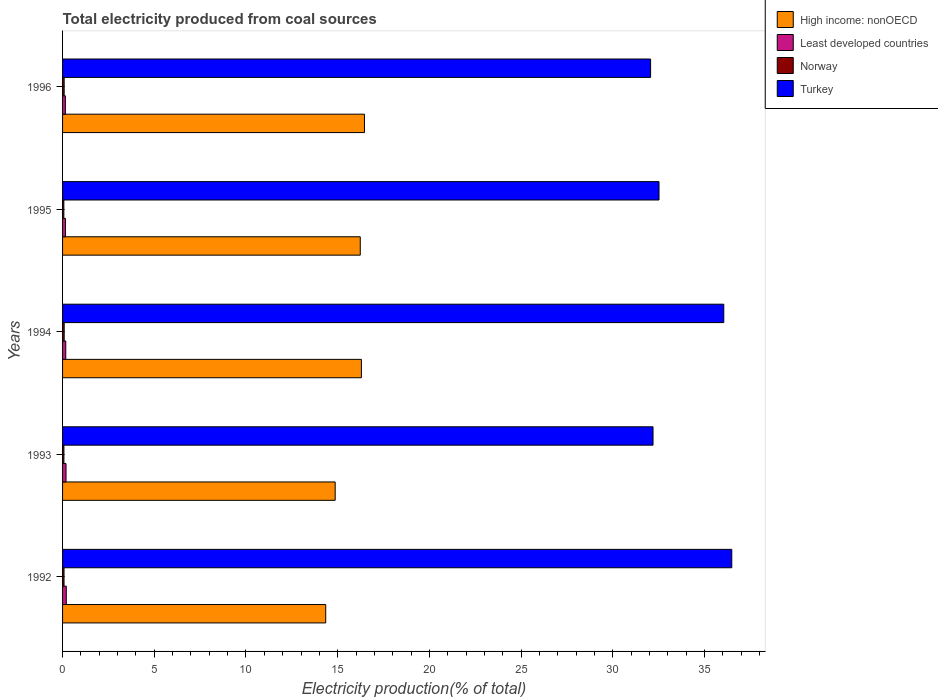How many different coloured bars are there?
Give a very brief answer. 4. Are the number of bars per tick equal to the number of legend labels?
Make the answer very short. Yes. Are the number of bars on each tick of the Y-axis equal?
Ensure brevity in your answer.  Yes. How many bars are there on the 5th tick from the top?
Ensure brevity in your answer.  4. What is the total electricity produced in Turkey in 1995?
Make the answer very short. 32.52. Across all years, what is the maximum total electricity produced in Least developed countries?
Provide a short and direct response. 0.2. Across all years, what is the minimum total electricity produced in Turkey?
Your answer should be very brief. 32.06. In which year was the total electricity produced in High income: nonOECD maximum?
Provide a succinct answer. 1996. What is the total total electricity produced in Turkey in the graph?
Provide a succinct answer. 169.31. What is the difference between the total electricity produced in Least developed countries in 1994 and that in 1995?
Provide a short and direct response. 0.02. What is the difference between the total electricity produced in High income: nonOECD in 1993 and the total electricity produced in Norway in 1992?
Keep it short and to the point. 14.78. What is the average total electricity produced in Least developed countries per year?
Your response must be concise. 0.18. In the year 1992, what is the difference between the total electricity produced in Least developed countries and total electricity produced in Norway?
Your answer should be compact. 0.12. In how many years, is the total electricity produced in Turkey greater than 36 %?
Offer a terse response. 2. What is the ratio of the total electricity produced in Norway in 1994 to that in 1995?
Provide a succinct answer. 1.27. What is the difference between the highest and the second highest total electricity produced in Least developed countries?
Your answer should be compact. 0.01. What is the difference between the highest and the lowest total electricity produced in Least developed countries?
Ensure brevity in your answer.  0.05. Is it the case that in every year, the sum of the total electricity produced in High income: nonOECD and total electricity produced in Least developed countries is greater than the sum of total electricity produced in Turkey and total electricity produced in Norway?
Provide a succinct answer. Yes. What does the 2nd bar from the top in 1996 represents?
Keep it short and to the point. Norway. What does the 2nd bar from the bottom in 1995 represents?
Keep it short and to the point. Least developed countries. Are all the bars in the graph horizontal?
Provide a succinct answer. Yes. How many years are there in the graph?
Keep it short and to the point. 5. What is the difference between two consecutive major ticks on the X-axis?
Ensure brevity in your answer.  5. Are the values on the major ticks of X-axis written in scientific E-notation?
Provide a short and direct response. No. Does the graph contain any zero values?
Your answer should be compact. No. How many legend labels are there?
Ensure brevity in your answer.  4. How are the legend labels stacked?
Ensure brevity in your answer.  Vertical. What is the title of the graph?
Offer a very short reply. Total electricity produced from coal sources. What is the label or title of the X-axis?
Give a very brief answer. Electricity production(% of total). What is the Electricity production(% of total) of High income: nonOECD in 1992?
Your answer should be compact. 14.35. What is the Electricity production(% of total) of Least developed countries in 1992?
Make the answer very short. 0.2. What is the Electricity production(% of total) of Norway in 1992?
Provide a short and direct response. 0.08. What is the Electricity production(% of total) of Turkey in 1992?
Make the answer very short. 36.49. What is the Electricity production(% of total) of High income: nonOECD in 1993?
Your answer should be compact. 14.86. What is the Electricity production(% of total) of Least developed countries in 1993?
Your answer should be compact. 0.19. What is the Electricity production(% of total) of Norway in 1993?
Your answer should be compact. 0.07. What is the Electricity production(% of total) of Turkey in 1993?
Keep it short and to the point. 32.19. What is the Electricity production(% of total) of High income: nonOECD in 1994?
Keep it short and to the point. 16.29. What is the Electricity production(% of total) in Least developed countries in 1994?
Make the answer very short. 0.17. What is the Electricity production(% of total) in Norway in 1994?
Make the answer very short. 0.09. What is the Electricity production(% of total) of Turkey in 1994?
Provide a succinct answer. 36.05. What is the Electricity production(% of total) in High income: nonOECD in 1995?
Keep it short and to the point. 16.23. What is the Electricity production(% of total) in Least developed countries in 1995?
Offer a terse response. 0.16. What is the Electricity production(% of total) in Norway in 1995?
Keep it short and to the point. 0.07. What is the Electricity production(% of total) in Turkey in 1995?
Offer a very short reply. 32.52. What is the Electricity production(% of total) of High income: nonOECD in 1996?
Provide a succinct answer. 16.46. What is the Electricity production(% of total) of Least developed countries in 1996?
Your answer should be compact. 0.15. What is the Electricity production(% of total) in Norway in 1996?
Your answer should be compact. 0.09. What is the Electricity production(% of total) in Turkey in 1996?
Your answer should be very brief. 32.06. Across all years, what is the maximum Electricity production(% of total) in High income: nonOECD?
Offer a terse response. 16.46. Across all years, what is the maximum Electricity production(% of total) of Least developed countries?
Your response must be concise. 0.2. Across all years, what is the maximum Electricity production(% of total) of Norway?
Provide a short and direct response. 0.09. Across all years, what is the maximum Electricity production(% of total) of Turkey?
Offer a terse response. 36.49. Across all years, what is the minimum Electricity production(% of total) in High income: nonOECD?
Your response must be concise. 14.35. Across all years, what is the minimum Electricity production(% of total) of Least developed countries?
Keep it short and to the point. 0.15. Across all years, what is the minimum Electricity production(% of total) in Norway?
Give a very brief answer. 0.07. Across all years, what is the minimum Electricity production(% of total) of Turkey?
Offer a terse response. 32.06. What is the total Electricity production(% of total) of High income: nonOECD in the graph?
Your answer should be compact. 78.19. What is the total Electricity production(% of total) in Least developed countries in the graph?
Your answer should be compact. 0.88. What is the total Electricity production(% of total) of Norway in the graph?
Provide a succinct answer. 0.4. What is the total Electricity production(% of total) in Turkey in the graph?
Ensure brevity in your answer.  169.31. What is the difference between the Electricity production(% of total) in High income: nonOECD in 1992 and that in 1993?
Offer a terse response. -0.52. What is the difference between the Electricity production(% of total) of Least developed countries in 1992 and that in 1993?
Your response must be concise. 0.01. What is the difference between the Electricity production(% of total) of Norway in 1992 and that in 1993?
Keep it short and to the point. 0.01. What is the difference between the Electricity production(% of total) of Turkey in 1992 and that in 1993?
Offer a terse response. 4.29. What is the difference between the Electricity production(% of total) of High income: nonOECD in 1992 and that in 1994?
Offer a very short reply. -1.95. What is the difference between the Electricity production(% of total) of Least developed countries in 1992 and that in 1994?
Provide a succinct answer. 0.03. What is the difference between the Electricity production(% of total) in Norway in 1992 and that in 1994?
Your response must be concise. -0.01. What is the difference between the Electricity production(% of total) in Turkey in 1992 and that in 1994?
Keep it short and to the point. 0.44. What is the difference between the Electricity production(% of total) in High income: nonOECD in 1992 and that in 1995?
Provide a short and direct response. -1.88. What is the difference between the Electricity production(% of total) of Least developed countries in 1992 and that in 1995?
Make the answer very short. 0.04. What is the difference between the Electricity production(% of total) of Norway in 1992 and that in 1995?
Make the answer very short. 0.01. What is the difference between the Electricity production(% of total) in Turkey in 1992 and that in 1995?
Give a very brief answer. 3.97. What is the difference between the Electricity production(% of total) of High income: nonOECD in 1992 and that in 1996?
Ensure brevity in your answer.  -2.11. What is the difference between the Electricity production(% of total) in Least developed countries in 1992 and that in 1996?
Ensure brevity in your answer.  0.05. What is the difference between the Electricity production(% of total) in Norway in 1992 and that in 1996?
Provide a short and direct response. -0.01. What is the difference between the Electricity production(% of total) in Turkey in 1992 and that in 1996?
Provide a short and direct response. 4.43. What is the difference between the Electricity production(% of total) of High income: nonOECD in 1993 and that in 1994?
Keep it short and to the point. -1.43. What is the difference between the Electricity production(% of total) of Least developed countries in 1993 and that in 1994?
Provide a succinct answer. 0.01. What is the difference between the Electricity production(% of total) of Norway in 1993 and that in 1994?
Your response must be concise. -0.01. What is the difference between the Electricity production(% of total) of Turkey in 1993 and that in 1994?
Your answer should be very brief. -3.86. What is the difference between the Electricity production(% of total) in High income: nonOECD in 1993 and that in 1995?
Your response must be concise. -1.37. What is the difference between the Electricity production(% of total) in Least developed countries in 1993 and that in 1995?
Make the answer very short. 0.03. What is the difference between the Electricity production(% of total) in Norway in 1993 and that in 1995?
Offer a terse response. 0. What is the difference between the Electricity production(% of total) in Turkey in 1993 and that in 1995?
Offer a terse response. -0.33. What is the difference between the Electricity production(% of total) of High income: nonOECD in 1993 and that in 1996?
Your response must be concise. -1.6. What is the difference between the Electricity production(% of total) of Least developed countries in 1993 and that in 1996?
Give a very brief answer. 0.04. What is the difference between the Electricity production(% of total) of Norway in 1993 and that in 1996?
Offer a very short reply. -0.01. What is the difference between the Electricity production(% of total) in Turkey in 1993 and that in 1996?
Keep it short and to the point. 0.13. What is the difference between the Electricity production(% of total) of High income: nonOECD in 1994 and that in 1995?
Keep it short and to the point. 0.06. What is the difference between the Electricity production(% of total) in Least developed countries in 1994 and that in 1995?
Make the answer very short. 0.02. What is the difference between the Electricity production(% of total) in Norway in 1994 and that in 1995?
Your answer should be very brief. 0.02. What is the difference between the Electricity production(% of total) of Turkey in 1994 and that in 1995?
Your answer should be very brief. 3.53. What is the difference between the Electricity production(% of total) in High income: nonOECD in 1994 and that in 1996?
Your answer should be very brief. -0.17. What is the difference between the Electricity production(% of total) of Least developed countries in 1994 and that in 1996?
Provide a succinct answer. 0.02. What is the difference between the Electricity production(% of total) of Norway in 1994 and that in 1996?
Offer a terse response. 0. What is the difference between the Electricity production(% of total) of Turkey in 1994 and that in 1996?
Your answer should be compact. 3.99. What is the difference between the Electricity production(% of total) of High income: nonOECD in 1995 and that in 1996?
Offer a terse response. -0.23. What is the difference between the Electricity production(% of total) in Least developed countries in 1995 and that in 1996?
Ensure brevity in your answer.  0.01. What is the difference between the Electricity production(% of total) of Norway in 1995 and that in 1996?
Make the answer very short. -0.02. What is the difference between the Electricity production(% of total) of Turkey in 1995 and that in 1996?
Your answer should be very brief. 0.46. What is the difference between the Electricity production(% of total) in High income: nonOECD in 1992 and the Electricity production(% of total) in Least developed countries in 1993?
Your response must be concise. 14.16. What is the difference between the Electricity production(% of total) in High income: nonOECD in 1992 and the Electricity production(% of total) in Norway in 1993?
Offer a very short reply. 14.27. What is the difference between the Electricity production(% of total) of High income: nonOECD in 1992 and the Electricity production(% of total) of Turkey in 1993?
Your answer should be compact. -17.85. What is the difference between the Electricity production(% of total) in Least developed countries in 1992 and the Electricity production(% of total) in Norway in 1993?
Keep it short and to the point. 0.13. What is the difference between the Electricity production(% of total) in Least developed countries in 1992 and the Electricity production(% of total) in Turkey in 1993?
Offer a very short reply. -31.99. What is the difference between the Electricity production(% of total) in Norway in 1992 and the Electricity production(% of total) in Turkey in 1993?
Ensure brevity in your answer.  -32.11. What is the difference between the Electricity production(% of total) of High income: nonOECD in 1992 and the Electricity production(% of total) of Least developed countries in 1994?
Your answer should be very brief. 14.17. What is the difference between the Electricity production(% of total) in High income: nonOECD in 1992 and the Electricity production(% of total) in Norway in 1994?
Your answer should be compact. 14.26. What is the difference between the Electricity production(% of total) of High income: nonOECD in 1992 and the Electricity production(% of total) of Turkey in 1994?
Offer a very short reply. -21.7. What is the difference between the Electricity production(% of total) in Least developed countries in 1992 and the Electricity production(% of total) in Norway in 1994?
Make the answer very short. 0.11. What is the difference between the Electricity production(% of total) of Least developed countries in 1992 and the Electricity production(% of total) of Turkey in 1994?
Make the answer very short. -35.85. What is the difference between the Electricity production(% of total) of Norway in 1992 and the Electricity production(% of total) of Turkey in 1994?
Make the answer very short. -35.97. What is the difference between the Electricity production(% of total) of High income: nonOECD in 1992 and the Electricity production(% of total) of Least developed countries in 1995?
Keep it short and to the point. 14.19. What is the difference between the Electricity production(% of total) in High income: nonOECD in 1992 and the Electricity production(% of total) in Norway in 1995?
Your answer should be compact. 14.28. What is the difference between the Electricity production(% of total) of High income: nonOECD in 1992 and the Electricity production(% of total) of Turkey in 1995?
Ensure brevity in your answer.  -18.17. What is the difference between the Electricity production(% of total) of Least developed countries in 1992 and the Electricity production(% of total) of Norway in 1995?
Provide a succinct answer. 0.13. What is the difference between the Electricity production(% of total) in Least developed countries in 1992 and the Electricity production(% of total) in Turkey in 1995?
Your response must be concise. -32.32. What is the difference between the Electricity production(% of total) of Norway in 1992 and the Electricity production(% of total) of Turkey in 1995?
Offer a terse response. -32.44. What is the difference between the Electricity production(% of total) of High income: nonOECD in 1992 and the Electricity production(% of total) of Least developed countries in 1996?
Ensure brevity in your answer.  14.2. What is the difference between the Electricity production(% of total) of High income: nonOECD in 1992 and the Electricity production(% of total) of Norway in 1996?
Provide a short and direct response. 14.26. What is the difference between the Electricity production(% of total) of High income: nonOECD in 1992 and the Electricity production(% of total) of Turkey in 1996?
Make the answer very short. -17.71. What is the difference between the Electricity production(% of total) of Least developed countries in 1992 and the Electricity production(% of total) of Norway in 1996?
Make the answer very short. 0.12. What is the difference between the Electricity production(% of total) of Least developed countries in 1992 and the Electricity production(% of total) of Turkey in 1996?
Make the answer very short. -31.86. What is the difference between the Electricity production(% of total) in Norway in 1992 and the Electricity production(% of total) in Turkey in 1996?
Give a very brief answer. -31.98. What is the difference between the Electricity production(% of total) of High income: nonOECD in 1993 and the Electricity production(% of total) of Least developed countries in 1994?
Provide a succinct answer. 14.69. What is the difference between the Electricity production(% of total) in High income: nonOECD in 1993 and the Electricity production(% of total) in Norway in 1994?
Your answer should be very brief. 14.77. What is the difference between the Electricity production(% of total) of High income: nonOECD in 1993 and the Electricity production(% of total) of Turkey in 1994?
Your response must be concise. -21.19. What is the difference between the Electricity production(% of total) of Least developed countries in 1993 and the Electricity production(% of total) of Norway in 1994?
Your answer should be very brief. 0.1. What is the difference between the Electricity production(% of total) in Least developed countries in 1993 and the Electricity production(% of total) in Turkey in 1994?
Ensure brevity in your answer.  -35.86. What is the difference between the Electricity production(% of total) in Norway in 1993 and the Electricity production(% of total) in Turkey in 1994?
Keep it short and to the point. -35.98. What is the difference between the Electricity production(% of total) of High income: nonOECD in 1993 and the Electricity production(% of total) of Least developed countries in 1995?
Keep it short and to the point. 14.7. What is the difference between the Electricity production(% of total) of High income: nonOECD in 1993 and the Electricity production(% of total) of Norway in 1995?
Your answer should be compact. 14.79. What is the difference between the Electricity production(% of total) in High income: nonOECD in 1993 and the Electricity production(% of total) in Turkey in 1995?
Keep it short and to the point. -17.66. What is the difference between the Electricity production(% of total) of Least developed countries in 1993 and the Electricity production(% of total) of Norway in 1995?
Provide a succinct answer. 0.12. What is the difference between the Electricity production(% of total) in Least developed countries in 1993 and the Electricity production(% of total) in Turkey in 1995?
Offer a very short reply. -32.33. What is the difference between the Electricity production(% of total) in Norway in 1993 and the Electricity production(% of total) in Turkey in 1995?
Offer a very short reply. -32.45. What is the difference between the Electricity production(% of total) of High income: nonOECD in 1993 and the Electricity production(% of total) of Least developed countries in 1996?
Your response must be concise. 14.71. What is the difference between the Electricity production(% of total) of High income: nonOECD in 1993 and the Electricity production(% of total) of Norway in 1996?
Give a very brief answer. 14.78. What is the difference between the Electricity production(% of total) in High income: nonOECD in 1993 and the Electricity production(% of total) in Turkey in 1996?
Offer a very short reply. -17.2. What is the difference between the Electricity production(% of total) of Least developed countries in 1993 and the Electricity production(% of total) of Norway in 1996?
Your response must be concise. 0.1. What is the difference between the Electricity production(% of total) of Least developed countries in 1993 and the Electricity production(% of total) of Turkey in 1996?
Keep it short and to the point. -31.87. What is the difference between the Electricity production(% of total) in Norway in 1993 and the Electricity production(% of total) in Turkey in 1996?
Offer a terse response. -31.99. What is the difference between the Electricity production(% of total) of High income: nonOECD in 1994 and the Electricity production(% of total) of Least developed countries in 1995?
Provide a short and direct response. 16.13. What is the difference between the Electricity production(% of total) in High income: nonOECD in 1994 and the Electricity production(% of total) in Norway in 1995?
Make the answer very short. 16.22. What is the difference between the Electricity production(% of total) of High income: nonOECD in 1994 and the Electricity production(% of total) of Turkey in 1995?
Provide a short and direct response. -16.23. What is the difference between the Electricity production(% of total) of Least developed countries in 1994 and the Electricity production(% of total) of Norway in 1995?
Offer a terse response. 0.1. What is the difference between the Electricity production(% of total) of Least developed countries in 1994 and the Electricity production(% of total) of Turkey in 1995?
Your answer should be compact. -32.35. What is the difference between the Electricity production(% of total) of Norway in 1994 and the Electricity production(% of total) of Turkey in 1995?
Give a very brief answer. -32.43. What is the difference between the Electricity production(% of total) in High income: nonOECD in 1994 and the Electricity production(% of total) in Least developed countries in 1996?
Your answer should be very brief. 16.14. What is the difference between the Electricity production(% of total) in High income: nonOECD in 1994 and the Electricity production(% of total) in Norway in 1996?
Give a very brief answer. 16.21. What is the difference between the Electricity production(% of total) of High income: nonOECD in 1994 and the Electricity production(% of total) of Turkey in 1996?
Keep it short and to the point. -15.77. What is the difference between the Electricity production(% of total) in Least developed countries in 1994 and the Electricity production(% of total) in Norway in 1996?
Provide a succinct answer. 0.09. What is the difference between the Electricity production(% of total) in Least developed countries in 1994 and the Electricity production(% of total) in Turkey in 1996?
Make the answer very short. -31.89. What is the difference between the Electricity production(% of total) in Norway in 1994 and the Electricity production(% of total) in Turkey in 1996?
Provide a short and direct response. -31.97. What is the difference between the Electricity production(% of total) of High income: nonOECD in 1995 and the Electricity production(% of total) of Least developed countries in 1996?
Keep it short and to the point. 16.08. What is the difference between the Electricity production(% of total) in High income: nonOECD in 1995 and the Electricity production(% of total) in Norway in 1996?
Offer a very short reply. 16.14. What is the difference between the Electricity production(% of total) of High income: nonOECD in 1995 and the Electricity production(% of total) of Turkey in 1996?
Keep it short and to the point. -15.83. What is the difference between the Electricity production(% of total) in Least developed countries in 1995 and the Electricity production(% of total) in Norway in 1996?
Provide a short and direct response. 0.07. What is the difference between the Electricity production(% of total) in Least developed countries in 1995 and the Electricity production(% of total) in Turkey in 1996?
Provide a short and direct response. -31.9. What is the difference between the Electricity production(% of total) of Norway in 1995 and the Electricity production(% of total) of Turkey in 1996?
Offer a terse response. -31.99. What is the average Electricity production(% of total) in High income: nonOECD per year?
Offer a very short reply. 15.64. What is the average Electricity production(% of total) in Least developed countries per year?
Provide a short and direct response. 0.18. What is the average Electricity production(% of total) of Norway per year?
Make the answer very short. 0.08. What is the average Electricity production(% of total) in Turkey per year?
Provide a succinct answer. 33.86. In the year 1992, what is the difference between the Electricity production(% of total) of High income: nonOECD and Electricity production(% of total) of Least developed countries?
Keep it short and to the point. 14.14. In the year 1992, what is the difference between the Electricity production(% of total) of High income: nonOECD and Electricity production(% of total) of Norway?
Provide a succinct answer. 14.27. In the year 1992, what is the difference between the Electricity production(% of total) in High income: nonOECD and Electricity production(% of total) in Turkey?
Offer a terse response. -22.14. In the year 1992, what is the difference between the Electricity production(% of total) in Least developed countries and Electricity production(% of total) in Norway?
Offer a very short reply. 0.12. In the year 1992, what is the difference between the Electricity production(% of total) of Least developed countries and Electricity production(% of total) of Turkey?
Ensure brevity in your answer.  -36.28. In the year 1992, what is the difference between the Electricity production(% of total) of Norway and Electricity production(% of total) of Turkey?
Keep it short and to the point. -36.41. In the year 1993, what is the difference between the Electricity production(% of total) in High income: nonOECD and Electricity production(% of total) in Least developed countries?
Your answer should be very brief. 14.67. In the year 1993, what is the difference between the Electricity production(% of total) of High income: nonOECD and Electricity production(% of total) of Norway?
Provide a succinct answer. 14.79. In the year 1993, what is the difference between the Electricity production(% of total) in High income: nonOECD and Electricity production(% of total) in Turkey?
Ensure brevity in your answer.  -17.33. In the year 1993, what is the difference between the Electricity production(% of total) in Least developed countries and Electricity production(% of total) in Norway?
Offer a terse response. 0.11. In the year 1993, what is the difference between the Electricity production(% of total) in Least developed countries and Electricity production(% of total) in Turkey?
Your response must be concise. -32. In the year 1993, what is the difference between the Electricity production(% of total) of Norway and Electricity production(% of total) of Turkey?
Keep it short and to the point. -32.12. In the year 1994, what is the difference between the Electricity production(% of total) of High income: nonOECD and Electricity production(% of total) of Least developed countries?
Provide a succinct answer. 16.12. In the year 1994, what is the difference between the Electricity production(% of total) of High income: nonOECD and Electricity production(% of total) of Norway?
Offer a very short reply. 16.2. In the year 1994, what is the difference between the Electricity production(% of total) in High income: nonOECD and Electricity production(% of total) in Turkey?
Provide a short and direct response. -19.76. In the year 1994, what is the difference between the Electricity production(% of total) of Least developed countries and Electricity production(% of total) of Norway?
Provide a short and direct response. 0.09. In the year 1994, what is the difference between the Electricity production(% of total) in Least developed countries and Electricity production(% of total) in Turkey?
Make the answer very short. -35.88. In the year 1994, what is the difference between the Electricity production(% of total) of Norway and Electricity production(% of total) of Turkey?
Keep it short and to the point. -35.96. In the year 1995, what is the difference between the Electricity production(% of total) in High income: nonOECD and Electricity production(% of total) in Least developed countries?
Keep it short and to the point. 16.07. In the year 1995, what is the difference between the Electricity production(% of total) of High income: nonOECD and Electricity production(% of total) of Norway?
Offer a terse response. 16.16. In the year 1995, what is the difference between the Electricity production(% of total) in High income: nonOECD and Electricity production(% of total) in Turkey?
Give a very brief answer. -16.29. In the year 1995, what is the difference between the Electricity production(% of total) in Least developed countries and Electricity production(% of total) in Norway?
Your response must be concise. 0.09. In the year 1995, what is the difference between the Electricity production(% of total) of Least developed countries and Electricity production(% of total) of Turkey?
Your answer should be compact. -32.36. In the year 1995, what is the difference between the Electricity production(% of total) in Norway and Electricity production(% of total) in Turkey?
Ensure brevity in your answer.  -32.45. In the year 1996, what is the difference between the Electricity production(% of total) of High income: nonOECD and Electricity production(% of total) of Least developed countries?
Offer a very short reply. 16.31. In the year 1996, what is the difference between the Electricity production(% of total) in High income: nonOECD and Electricity production(% of total) in Norway?
Your response must be concise. 16.37. In the year 1996, what is the difference between the Electricity production(% of total) of High income: nonOECD and Electricity production(% of total) of Turkey?
Keep it short and to the point. -15.6. In the year 1996, what is the difference between the Electricity production(% of total) in Least developed countries and Electricity production(% of total) in Norway?
Offer a terse response. 0.07. In the year 1996, what is the difference between the Electricity production(% of total) of Least developed countries and Electricity production(% of total) of Turkey?
Make the answer very short. -31.91. In the year 1996, what is the difference between the Electricity production(% of total) in Norway and Electricity production(% of total) in Turkey?
Offer a terse response. -31.97. What is the ratio of the Electricity production(% of total) in High income: nonOECD in 1992 to that in 1993?
Your answer should be very brief. 0.97. What is the ratio of the Electricity production(% of total) of Least developed countries in 1992 to that in 1993?
Offer a terse response. 1.08. What is the ratio of the Electricity production(% of total) of Norway in 1992 to that in 1993?
Ensure brevity in your answer.  1.08. What is the ratio of the Electricity production(% of total) of Turkey in 1992 to that in 1993?
Your response must be concise. 1.13. What is the ratio of the Electricity production(% of total) in High income: nonOECD in 1992 to that in 1994?
Make the answer very short. 0.88. What is the ratio of the Electricity production(% of total) in Least developed countries in 1992 to that in 1994?
Make the answer very short. 1.16. What is the ratio of the Electricity production(% of total) in Norway in 1992 to that in 1994?
Offer a very short reply. 0.91. What is the ratio of the Electricity production(% of total) in Turkey in 1992 to that in 1994?
Give a very brief answer. 1.01. What is the ratio of the Electricity production(% of total) of High income: nonOECD in 1992 to that in 1995?
Ensure brevity in your answer.  0.88. What is the ratio of the Electricity production(% of total) in Least developed countries in 1992 to that in 1995?
Provide a succinct answer. 1.28. What is the ratio of the Electricity production(% of total) of Norway in 1992 to that in 1995?
Give a very brief answer. 1.15. What is the ratio of the Electricity production(% of total) in Turkey in 1992 to that in 1995?
Your response must be concise. 1.12. What is the ratio of the Electricity production(% of total) of High income: nonOECD in 1992 to that in 1996?
Offer a terse response. 0.87. What is the ratio of the Electricity production(% of total) of Least developed countries in 1992 to that in 1996?
Provide a succinct answer. 1.34. What is the ratio of the Electricity production(% of total) in Norway in 1992 to that in 1996?
Your answer should be very brief. 0.92. What is the ratio of the Electricity production(% of total) in Turkey in 1992 to that in 1996?
Offer a very short reply. 1.14. What is the ratio of the Electricity production(% of total) in High income: nonOECD in 1993 to that in 1994?
Your answer should be compact. 0.91. What is the ratio of the Electricity production(% of total) in Least developed countries in 1993 to that in 1994?
Offer a very short reply. 1.08. What is the ratio of the Electricity production(% of total) in Norway in 1993 to that in 1994?
Ensure brevity in your answer.  0.84. What is the ratio of the Electricity production(% of total) in Turkey in 1993 to that in 1994?
Your response must be concise. 0.89. What is the ratio of the Electricity production(% of total) of High income: nonOECD in 1993 to that in 1995?
Your answer should be compact. 0.92. What is the ratio of the Electricity production(% of total) of Least developed countries in 1993 to that in 1995?
Offer a very short reply. 1.18. What is the ratio of the Electricity production(% of total) in Norway in 1993 to that in 1995?
Provide a short and direct response. 1.07. What is the ratio of the Electricity production(% of total) of High income: nonOECD in 1993 to that in 1996?
Keep it short and to the point. 0.9. What is the ratio of the Electricity production(% of total) of Least developed countries in 1993 to that in 1996?
Ensure brevity in your answer.  1.24. What is the ratio of the Electricity production(% of total) in Norway in 1993 to that in 1996?
Give a very brief answer. 0.86. What is the ratio of the Electricity production(% of total) in Turkey in 1993 to that in 1996?
Offer a terse response. 1. What is the ratio of the Electricity production(% of total) in High income: nonOECD in 1994 to that in 1995?
Offer a terse response. 1. What is the ratio of the Electricity production(% of total) of Least developed countries in 1994 to that in 1995?
Offer a terse response. 1.09. What is the ratio of the Electricity production(% of total) of Norway in 1994 to that in 1995?
Ensure brevity in your answer.  1.27. What is the ratio of the Electricity production(% of total) in Turkey in 1994 to that in 1995?
Provide a succinct answer. 1.11. What is the ratio of the Electricity production(% of total) of Least developed countries in 1994 to that in 1996?
Your response must be concise. 1.15. What is the ratio of the Electricity production(% of total) of Norway in 1994 to that in 1996?
Your response must be concise. 1.01. What is the ratio of the Electricity production(% of total) of Turkey in 1994 to that in 1996?
Your answer should be very brief. 1.12. What is the ratio of the Electricity production(% of total) of High income: nonOECD in 1995 to that in 1996?
Offer a terse response. 0.99. What is the ratio of the Electricity production(% of total) of Least developed countries in 1995 to that in 1996?
Ensure brevity in your answer.  1.05. What is the ratio of the Electricity production(% of total) in Turkey in 1995 to that in 1996?
Make the answer very short. 1.01. What is the difference between the highest and the second highest Electricity production(% of total) of High income: nonOECD?
Keep it short and to the point. 0.17. What is the difference between the highest and the second highest Electricity production(% of total) of Least developed countries?
Provide a short and direct response. 0.01. What is the difference between the highest and the second highest Electricity production(% of total) in Norway?
Offer a terse response. 0. What is the difference between the highest and the second highest Electricity production(% of total) of Turkey?
Ensure brevity in your answer.  0.44. What is the difference between the highest and the lowest Electricity production(% of total) of High income: nonOECD?
Provide a succinct answer. 2.11. What is the difference between the highest and the lowest Electricity production(% of total) of Least developed countries?
Keep it short and to the point. 0.05. What is the difference between the highest and the lowest Electricity production(% of total) in Norway?
Your answer should be compact. 0.02. What is the difference between the highest and the lowest Electricity production(% of total) of Turkey?
Your answer should be very brief. 4.43. 